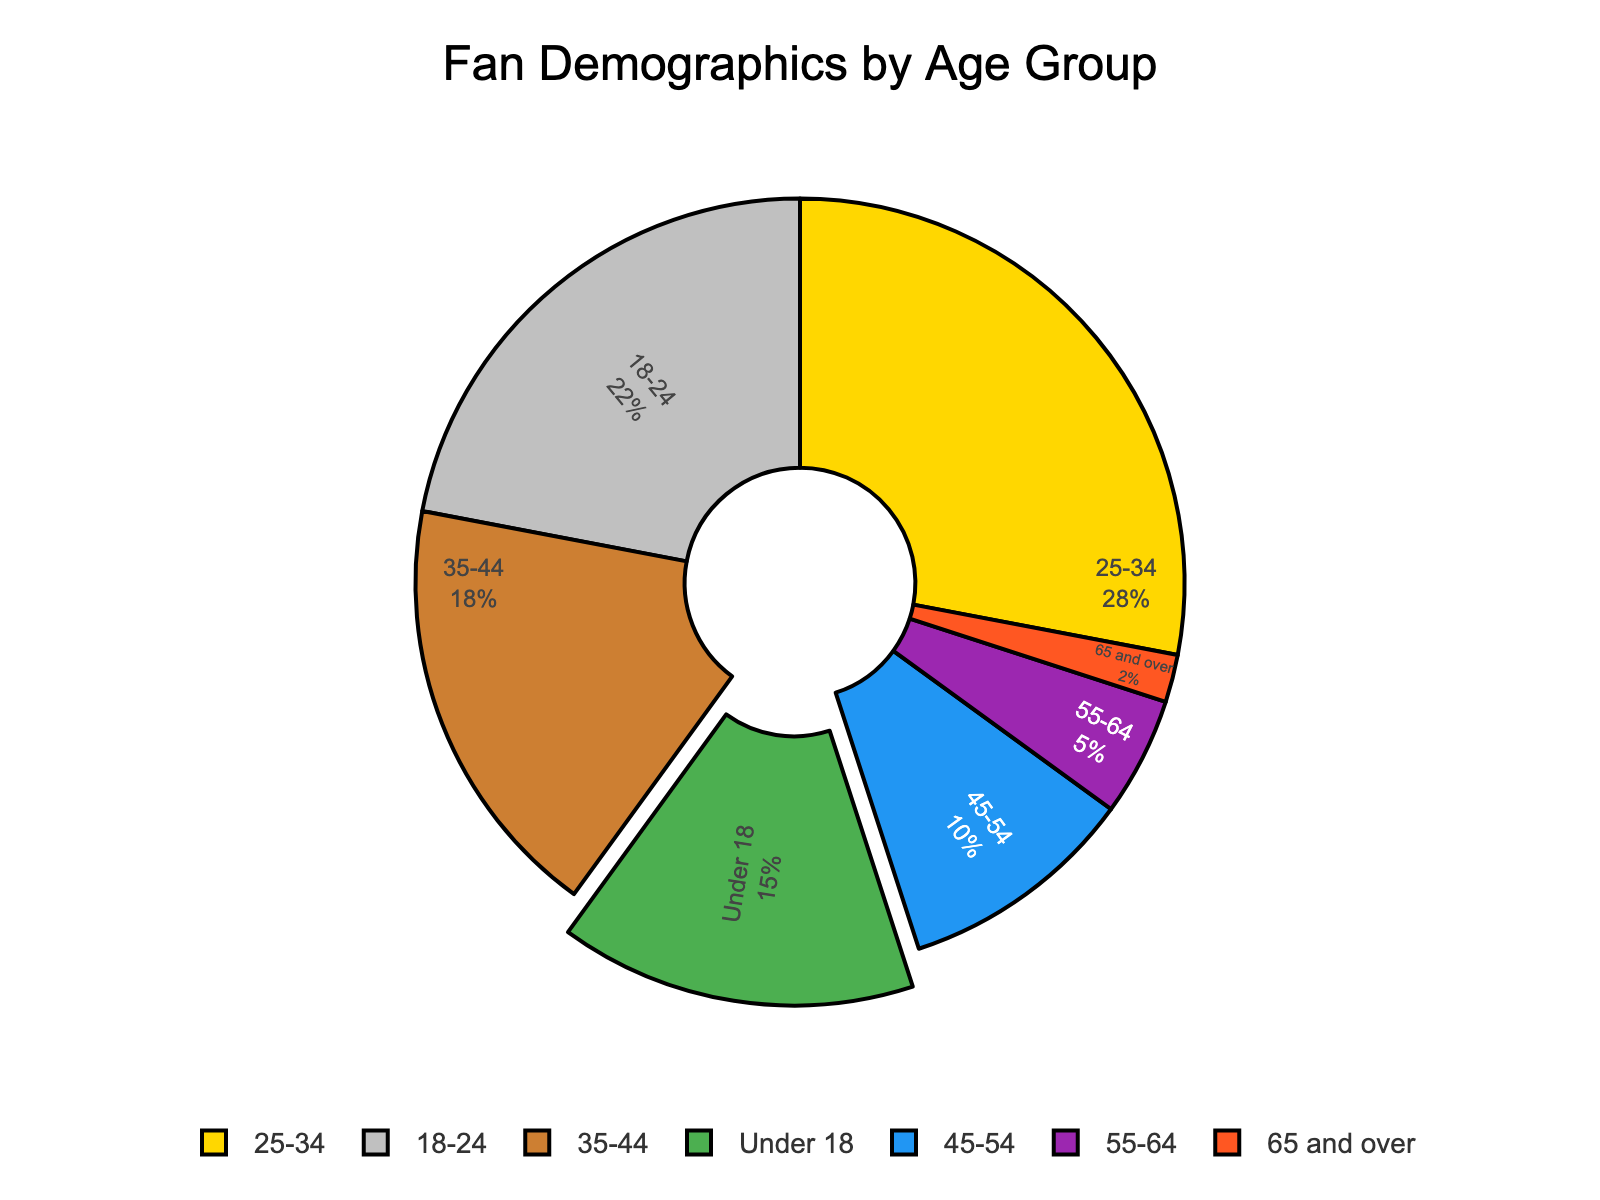Which age group has the highest percentage of fans? The age group with the highest percentage is identified by the largest slice in the pie chart, which corresponds to 25-34.
Answer: 25-34 Which two age groups together constitute more than 50% of the fans? Adding the percentages of each age group to find the pairs that exceed 50%: 25-34 (28%) and 18-24 (22%) together make 50%, which is the closest pair totaling more than half. Checking further confirms no other pair exceeds 50%.
Answer: 25-34 and 18-24 What percentage of fans are either below 18 or over 45? Adding the percentage of fans under 18 (15%) and those aged 45 and above (45-54 at 10%, 55-64 at 5%, 65 and over at 2%) gives a total. Calculating: 15% + 10% + 5% + 2% = 32%.
Answer: 32% Which is larger: the percentage of fans aged 35-44 or the combined percentage of fans aged 45-54 and 55-64? Comparing 18% (35-44) to the sum of 45-54 (10%) and 55-64 (5%): 18% vs. 15%. Performing subtraction: 18% - 15% = 3%. Therefore, fans aged 35-44 constitute a larger percentage.
Answer: Fans aged 35-44 What can you infer about the fanbase of those above 55 based on their combined percentage? Combining the percentages of those aged 55-64 (5%) and those 65 and over (2%): 5% + 2% = 7%. Fans above 55 make up a relatively small part of the fanbase.
Answer: They form 7% of the fanbase Which age group has the smallest fan percentage, and what is it? Identifying the smallest slice in the pie chart with the smallest numerical value, corresponds to 65 and over age group.
Answer: 65 and over, 2% Compare the similarities and differences in percentage between fans aged 18-24 and those aged 35-44 Fans aged 18-24 (22%) are slightly more than those aged 35-44 (18%). Comparing calculations: 22% - 18% = 4%. While close in value, 18-24 has a higher percentage.
Answer: 18-24 is 4% more than 35-44 What is the combined percentage of fans between the ages 25 and 44? Adding the percentages of age groups 25-34 (28%) and 35-44 (18%): 28% + 18% = 46%.
Answer: 46% How much more significant is the percentage of fans aged 25-34 compared to those aged 55-64? Subtracting the percentage of fans aged 55-64 (5%) from those aged 25-34 (28%): 28% - 5% = 23%.
Answer: 23% more significant What color represents the age group 18-24 in the pie chart? By referring to the defined color palette used, the second color in the palette applied to the second-listed age group aligns with silver representation for 18-24.
Answer: Silver 